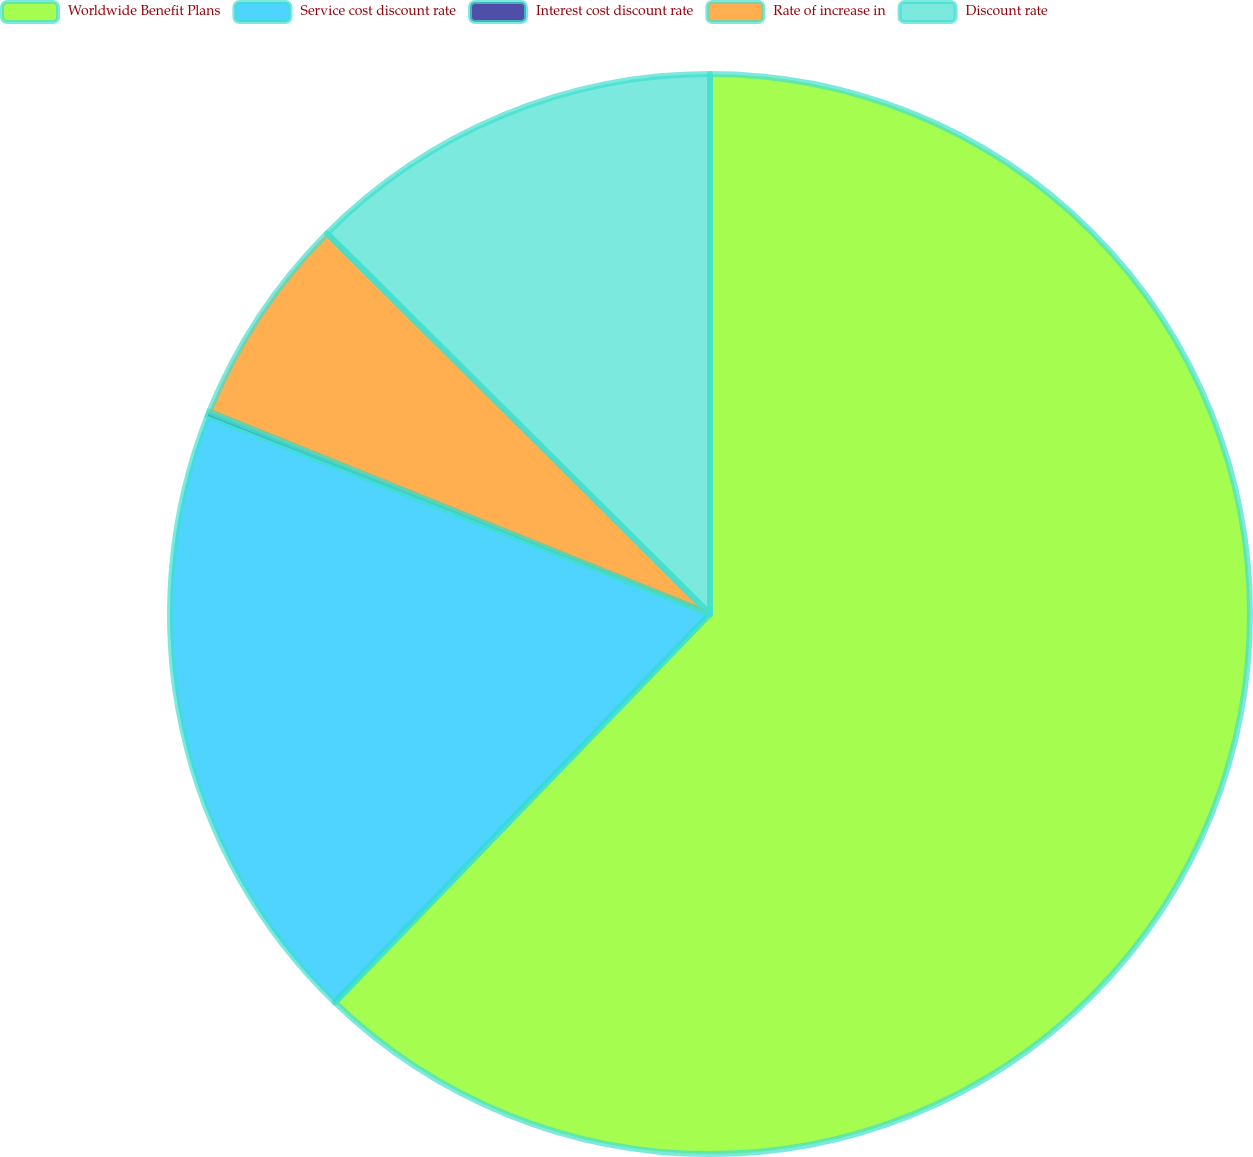Convert chart to OTSL. <chart><loc_0><loc_0><loc_500><loc_500><pie_chart><fcel>Worldwide Benefit Plans<fcel>Service cost discount rate<fcel>Interest cost discount rate<fcel>Rate of increase in<fcel>Discount rate<nl><fcel>62.23%<fcel>18.76%<fcel>0.13%<fcel>6.34%<fcel>12.55%<nl></chart> 